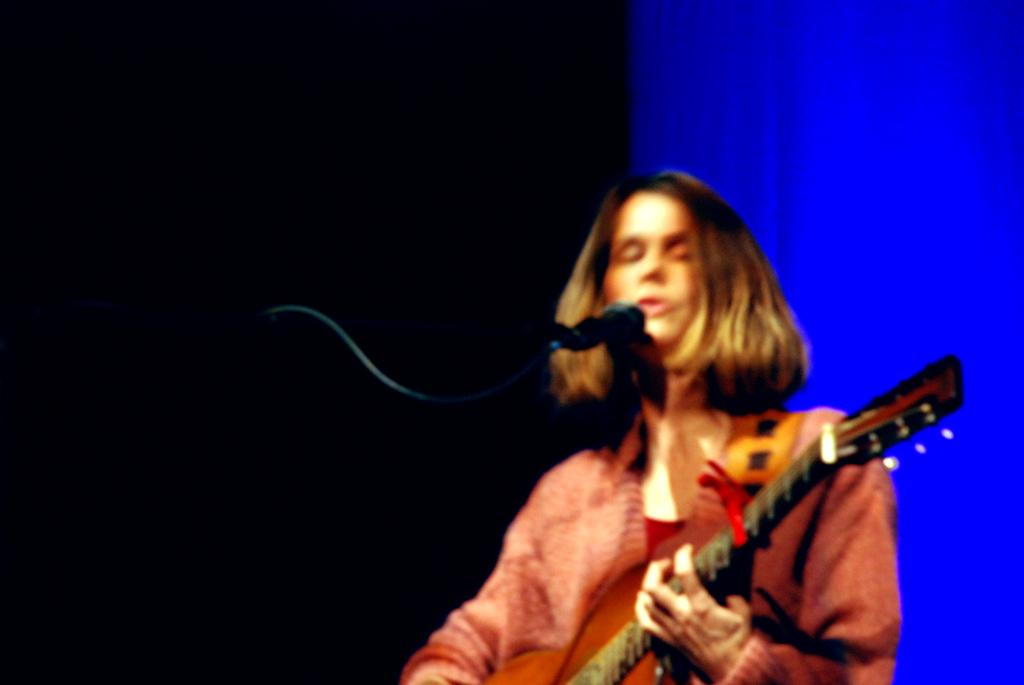What is the person in the image doing? The person is playing a musical instrument and singing into a microphone. What can be inferred about the person's activity in the image? The person is likely performing or practicing music. What is the color scheme of the background in the image? The background in the image has a blue and black color scheme. How many twigs are the person using to support their musical instrument in the image? There are no twigs visible in the image, and the person is not using any twigs to support their musical instrument. 